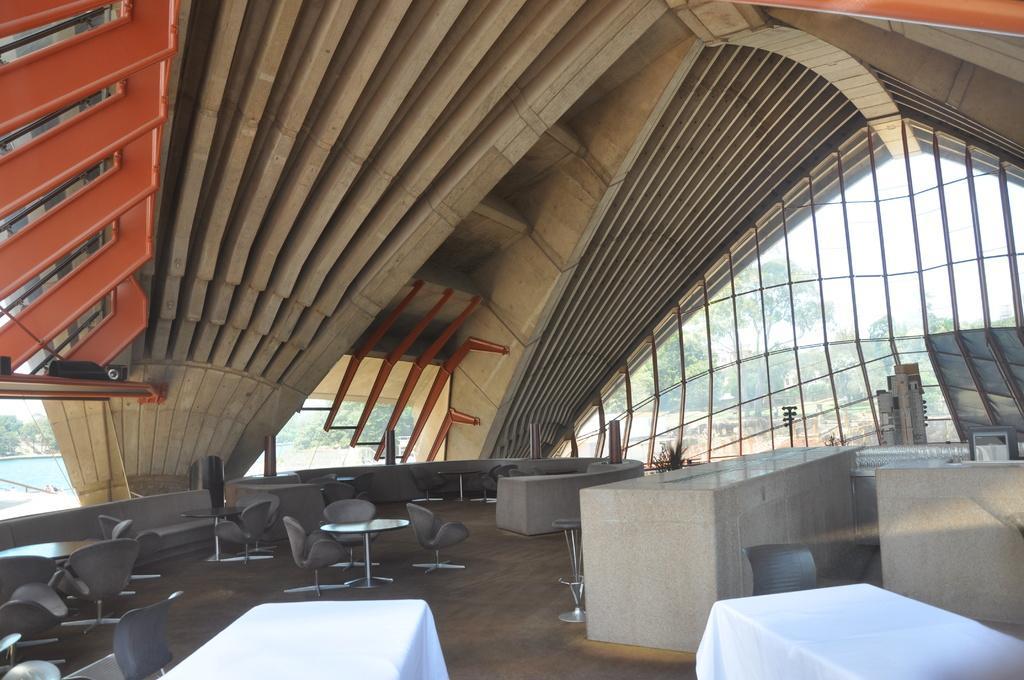In one or two sentences, can you explain what this image depicts? This image is clicked inside the building. At the bottom, there are chairs and table. There are two chairs covered with white clothes. In the background, we can see the walls, and trees through the glass. 